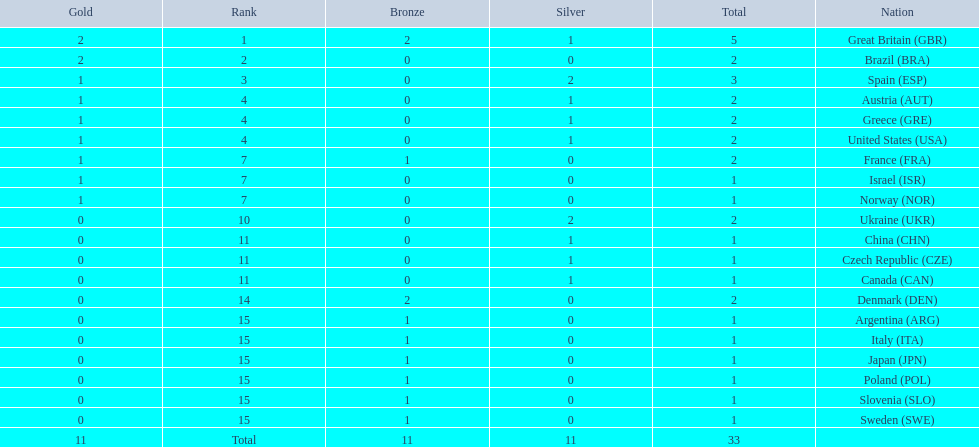What nation was next to great britain in total medal count? Spain. 